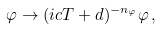<formula> <loc_0><loc_0><loc_500><loc_500>\varphi \rightarrow ( i c T + d ) ^ { - n _ { \varphi } } \varphi \, ,</formula> 